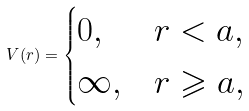Convert formula to latex. <formula><loc_0><loc_0><loc_500><loc_500>V ( r ) = \begin{cases} 0 , & r < a , \\ \infty , & r \geqslant a , \end{cases}</formula> 